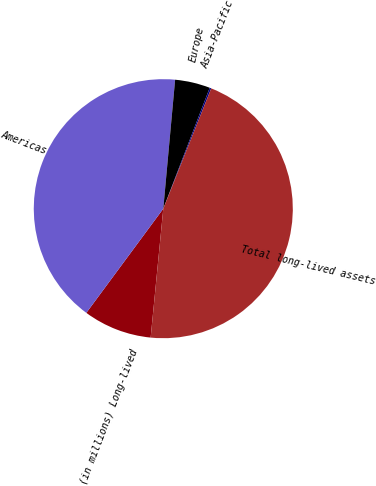Convert chart. <chart><loc_0><loc_0><loc_500><loc_500><pie_chart><fcel>(in millions) Long-lived<fcel>Americas<fcel>Europe<fcel>Asia-Pacific<fcel>Total long-lived assets<nl><fcel>8.57%<fcel>41.33%<fcel>4.38%<fcel>0.2%<fcel>45.52%<nl></chart> 